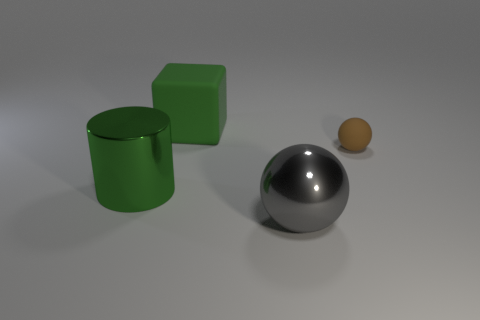There is a shiny thing to the left of the green rubber thing; is its color the same as the rubber object that is behind the tiny matte object?
Give a very brief answer. Yes. How many other things are there of the same shape as the brown thing?
Your answer should be very brief. 1. Is there a tiny red rubber cube?
Keep it short and to the point. No. What number of objects are either large green metal cylinders or large green things in front of the matte cube?
Ensure brevity in your answer.  1. There is a green thing that is in front of the green rubber block; is its size the same as the rubber cube?
Give a very brief answer. Yes. What number of other objects are the same size as the metallic cylinder?
Offer a terse response. 2. What color is the rubber block?
Offer a terse response. Green. What is the large green object that is in front of the big matte block made of?
Offer a terse response. Metal. Are there the same number of big metallic balls that are on the left side of the big gray object and brown rubber cubes?
Ensure brevity in your answer.  Yes. Is the gray metallic thing the same shape as the large green metal thing?
Provide a short and direct response. No. 